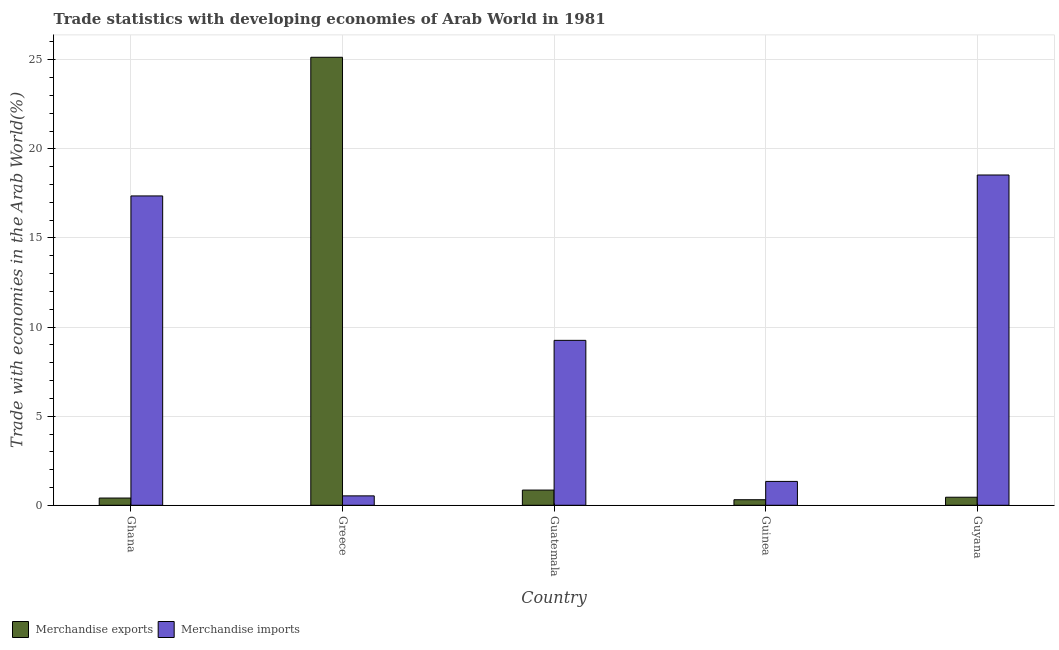How many different coloured bars are there?
Your response must be concise. 2. Are the number of bars on each tick of the X-axis equal?
Keep it short and to the point. Yes. What is the label of the 2nd group of bars from the left?
Provide a succinct answer. Greece. In how many cases, is the number of bars for a given country not equal to the number of legend labels?
Ensure brevity in your answer.  0. What is the merchandise exports in Greece?
Your response must be concise. 25.14. Across all countries, what is the maximum merchandise imports?
Provide a succinct answer. 18.54. Across all countries, what is the minimum merchandise exports?
Ensure brevity in your answer.  0.31. In which country was the merchandise imports maximum?
Make the answer very short. Guyana. In which country was the merchandise exports minimum?
Offer a terse response. Guinea. What is the total merchandise exports in the graph?
Make the answer very short. 27.16. What is the difference between the merchandise exports in Guatemala and that in Guinea?
Your response must be concise. 0.54. What is the difference between the merchandise imports in Guinea and the merchandise exports in Greece?
Give a very brief answer. -23.8. What is the average merchandise exports per country?
Provide a succinct answer. 5.43. What is the difference between the merchandise exports and merchandise imports in Guinea?
Give a very brief answer. -1.03. In how many countries, is the merchandise imports greater than 5 %?
Ensure brevity in your answer.  3. What is the ratio of the merchandise exports in Ghana to that in Guatemala?
Keep it short and to the point. 0.48. Is the merchandise imports in Guatemala less than that in Guinea?
Give a very brief answer. No. What is the difference between the highest and the second highest merchandise exports?
Your answer should be very brief. 24.29. What is the difference between the highest and the lowest merchandise exports?
Keep it short and to the point. 24.83. Is the sum of the merchandise exports in Greece and Guyana greater than the maximum merchandise imports across all countries?
Your response must be concise. Yes. What does the 1st bar from the left in Guatemala represents?
Offer a terse response. Merchandise exports. How many countries are there in the graph?
Offer a terse response. 5. What is the difference between two consecutive major ticks on the Y-axis?
Give a very brief answer. 5. Are the values on the major ticks of Y-axis written in scientific E-notation?
Make the answer very short. No. Where does the legend appear in the graph?
Make the answer very short. Bottom left. How many legend labels are there?
Offer a very short reply. 2. What is the title of the graph?
Your response must be concise. Trade statistics with developing economies of Arab World in 1981. What is the label or title of the Y-axis?
Make the answer very short. Trade with economies in the Arab World(%). What is the Trade with economies in the Arab World(%) of Merchandise exports in Ghana?
Give a very brief answer. 0.41. What is the Trade with economies in the Arab World(%) of Merchandise imports in Ghana?
Give a very brief answer. 17.36. What is the Trade with economies in the Arab World(%) of Merchandise exports in Greece?
Provide a succinct answer. 25.14. What is the Trade with economies in the Arab World(%) of Merchandise imports in Greece?
Provide a succinct answer. 0.53. What is the Trade with economies in the Arab World(%) of Merchandise exports in Guatemala?
Offer a very short reply. 0.85. What is the Trade with economies in the Arab World(%) of Merchandise imports in Guatemala?
Offer a very short reply. 9.26. What is the Trade with economies in the Arab World(%) of Merchandise exports in Guinea?
Provide a short and direct response. 0.31. What is the Trade with economies in the Arab World(%) of Merchandise imports in Guinea?
Give a very brief answer. 1.34. What is the Trade with economies in the Arab World(%) of Merchandise exports in Guyana?
Make the answer very short. 0.45. What is the Trade with economies in the Arab World(%) in Merchandise imports in Guyana?
Ensure brevity in your answer.  18.54. Across all countries, what is the maximum Trade with economies in the Arab World(%) of Merchandise exports?
Your response must be concise. 25.14. Across all countries, what is the maximum Trade with economies in the Arab World(%) in Merchandise imports?
Offer a terse response. 18.54. Across all countries, what is the minimum Trade with economies in the Arab World(%) of Merchandise exports?
Keep it short and to the point. 0.31. Across all countries, what is the minimum Trade with economies in the Arab World(%) of Merchandise imports?
Offer a very short reply. 0.53. What is the total Trade with economies in the Arab World(%) of Merchandise exports in the graph?
Provide a succinct answer. 27.16. What is the total Trade with economies in the Arab World(%) in Merchandise imports in the graph?
Your answer should be compact. 47.02. What is the difference between the Trade with economies in the Arab World(%) in Merchandise exports in Ghana and that in Greece?
Your answer should be very brief. -24.74. What is the difference between the Trade with economies in the Arab World(%) of Merchandise imports in Ghana and that in Greece?
Offer a very short reply. 16.83. What is the difference between the Trade with economies in the Arab World(%) of Merchandise exports in Ghana and that in Guatemala?
Provide a succinct answer. -0.45. What is the difference between the Trade with economies in the Arab World(%) in Merchandise imports in Ghana and that in Guatemala?
Provide a short and direct response. 8.1. What is the difference between the Trade with economies in the Arab World(%) of Merchandise exports in Ghana and that in Guinea?
Your answer should be very brief. 0.09. What is the difference between the Trade with economies in the Arab World(%) of Merchandise imports in Ghana and that in Guinea?
Offer a terse response. 16.02. What is the difference between the Trade with economies in the Arab World(%) in Merchandise exports in Ghana and that in Guyana?
Your answer should be very brief. -0.05. What is the difference between the Trade with economies in the Arab World(%) of Merchandise imports in Ghana and that in Guyana?
Provide a short and direct response. -1.18. What is the difference between the Trade with economies in the Arab World(%) of Merchandise exports in Greece and that in Guatemala?
Provide a short and direct response. 24.29. What is the difference between the Trade with economies in the Arab World(%) in Merchandise imports in Greece and that in Guatemala?
Ensure brevity in your answer.  -8.73. What is the difference between the Trade with economies in the Arab World(%) of Merchandise exports in Greece and that in Guinea?
Make the answer very short. 24.83. What is the difference between the Trade with economies in the Arab World(%) of Merchandise imports in Greece and that in Guinea?
Your answer should be very brief. -0.81. What is the difference between the Trade with economies in the Arab World(%) of Merchandise exports in Greece and that in Guyana?
Ensure brevity in your answer.  24.69. What is the difference between the Trade with economies in the Arab World(%) of Merchandise imports in Greece and that in Guyana?
Offer a terse response. -18.01. What is the difference between the Trade with economies in the Arab World(%) of Merchandise exports in Guatemala and that in Guinea?
Your answer should be compact. 0.54. What is the difference between the Trade with economies in the Arab World(%) of Merchandise imports in Guatemala and that in Guinea?
Your answer should be compact. 7.92. What is the difference between the Trade with economies in the Arab World(%) in Merchandise exports in Guatemala and that in Guyana?
Offer a terse response. 0.4. What is the difference between the Trade with economies in the Arab World(%) in Merchandise imports in Guatemala and that in Guyana?
Make the answer very short. -9.28. What is the difference between the Trade with economies in the Arab World(%) of Merchandise exports in Guinea and that in Guyana?
Your answer should be compact. -0.14. What is the difference between the Trade with economies in the Arab World(%) of Merchandise imports in Guinea and that in Guyana?
Provide a succinct answer. -17.2. What is the difference between the Trade with economies in the Arab World(%) of Merchandise exports in Ghana and the Trade with economies in the Arab World(%) of Merchandise imports in Greece?
Your answer should be compact. -0.12. What is the difference between the Trade with economies in the Arab World(%) of Merchandise exports in Ghana and the Trade with economies in the Arab World(%) of Merchandise imports in Guatemala?
Provide a succinct answer. -8.85. What is the difference between the Trade with economies in the Arab World(%) in Merchandise exports in Ghana and the Trade with economies in the Arab World(%) in Merchandise imports in Guinea?
Keep it short and to the point. -0.93. What is the difference between the Trade with economies in the Arab World(%) of Merchandise exports in Ghana and the Trade with economies in the Arab World(%) of Merchandise imports in Guyana?
Offer a terse response. -18.13. What is the difference between the Trade with economies in the Arab World(%) in Merchandise exports in Greece and the Trade with economies in the Arab World(%) in Merchandise imports in Guatemala?
Your response must be concise. 15.89. What is the difference between the Trade with economies in the Arab World(%) of Merchandise exports in Greece and the Trade with economies in the Arab World(%) of Merchandise imports in Guinea?
Make the answer very short. 23.8. What is the difference between the Trade with economies in the Arab World(%) in Merchandise exports in Greece and the Trade with economies in the Arab World(%) in Merchandise imports in Guyana?
Keep it short and to the point. 6.61. What is the difference between the Trade with economies in the Arab World(%) in Merchandise exports in Guatemala and the Trade with economies in the Arab World(%) in Merchandise imports in Guinea?
Provide a succinct answer. -0.49. What is the difference between the Trade with economies in the Arab World(%) of Merchandise exports in Guatemala and the Trade with economies in the Arab World(%) of Merchandise imports in Guyana?
Your answer should be compact. -17.68. What is the difference between the Trade with economies in the Arab World(%) in Merchandise exports in Guinea and the Trade with economies in the Arab World(%) in Merchandise imports in Guyana?
Ensure brevity in your answer.  -18.22. What is the average Trade with economies in the Arab World(%) in Merchandise exports per country?
Provide a short and direct response. 5.43. What is the average Trade with economies in the Arab World(%) in Merchandise imports per country?
Offer a very short reply. 9.4. What is the difference between the Trade with economies in the Arab World(%) of Merchandise exports and Trade with economies in the Arab World(%) of Merchandise imports in Ghana?
Your answer should be compact. -16.95. What is the difference between the Trade with economies in the Arab World(%) of Merchandise exports and Trade with economies in the Arab World(%) of Merchandise imports in Greece?
Ensure brevity in your answer.  24.61. What is the difference between the Trade with economies in the Arab World(%) of Merchandise exports and Trade with economies in the Arab World(%) of Merchandise imports in Guatemala?
Provide a short and direct response. -8.4. What is the difference between the Trade with economies in the Arab World(%) of Merchandise exports and Trade with economies in the Arab World(%) of Merchandise imports in Guinea?
Offer a very short reply. -1.03. What is the difference between the Trade with economies in the Arab World(%) in Merchandise exports and Trade with economies in the Arab World(%) in Merchandise imports in Guyana?
Provide a short and direct response. -18.08. What is the ratio of the Trade with economies in the Arab World(%) of Merchandise exports in Ghana to that in Greece?
Offer a terse response. 0.02. What is the ratio of the Trade with economies in the Arab World(%) of Merchandise imports in Ghana to that in Greece?
Offer a very short reply. 32.9. What is the ratio of the Trade with economies in the Arab World(%) of Merchandise exports in Ghana to that in Guatemala?
Your response must be concise. 0.48. What is the ratio of the Trade with economies in the Arab World(%) of Merchandise imports in Ghana to that in Guatemala?
Your answer should be very brief. 1.88. What is the ratio of the Trade with economies in the Arab World(%) in Merchandise exports in Ghana to that in Guinea?
Provide a short and direct response. 1.3. What is the ratio of the Trade with economies in the Arab World(%) in Merchandise imports in Ghana to that in Guinea?
Provide a succinct answer. 12.96. What is the ratio of the Trade with economies in the Arab World(%) in Merchandise exports in Ghana to that in Guyana?
Keep it short and to the point. 0.9. What is the ratio of the Trade with economies in the Arab World(%) of Merchandise imports in Ghana to that in Guyana?
Make the answer very short. 0.94. What is the ratio of the Trade with economies in the Arab World(%) of Merchandise exports in Greece to that in Guatemala?
Your answer should be compact. 29.48. What is the ratio of the Trade with economies in the Arab World(%) of Merchandise imports in Greece to that in Guatemala?
Provide a succinct answer. 0.06. What is the ratio of the Trade with economies in the Arab World(%) in Merchandise exports in Greece to that in Guinea?
Your response must be concise. 80.77. What is the ratio of the Trade with economies in the Arab World(%) in Merchandise imports in Greece to that in Guinea?
Your answer should be very brief. 0.39. What is the ratio of the Trade with economies in the Arab World(%) in Merchandise exports in Greece to that in Guyana?
Your response must be concise. 55.71. What is the ratio of the Trade with economies in the Arab World(%) of Merchandise imports in Greece to that in Guyana?
Provide a succinct answer. 0.03. What is the ratio of the Trade with economies in the Arab World(%) in Merchandise exports in Guatemala to that in Guinea?
Provide a succinct answer. 2.74. What is the ratio of the Trade with economies in the Arab World(%) in Merchandise imports in Guatemala to that in Guinea?
Provide a short and direct response. 6.91. What is the ratio of the Trade with economies in the Arab World(%) of Merchandise exports in Guatemala to that in Guyana?
Offer a terse response. 1.89. What is the ratio of the Trade with economies in the Arab World(%) of Merchandise imports in Guatemala to that in Guyana?
Offer a very short reply. 0.5. What is the ratio of the Trade with economies in the Arab World(%) of Merchandise exports in Guinea to that in Guyana?
Provide a short and direct response. 0.69. What is the ratio of the Trade with economies in the Arab World(%) of Merchandise imports in Guinea to that in Guyana?
Your response must be concise. 0.07. What is the difference between the highest and the second highest Trade with economies in the Arab World(%) of Merchandise exports?
Your answer should be compact. 24.29. What is the difference between the highest and the second highest Trade with economies in the Arab World(%) of Merchandise imports?
Give a very brief answer. 1.18. What is the difference between the highest and the lowest Trade with economies in the Arab World(%) of Merchandise exports?
Keep it short and to the point. 24.83. What is the difference between the highest and the lowest Trade with economies in the Arab World(%) in Merchandise imports?
Your answer should be compact. 18.01. 